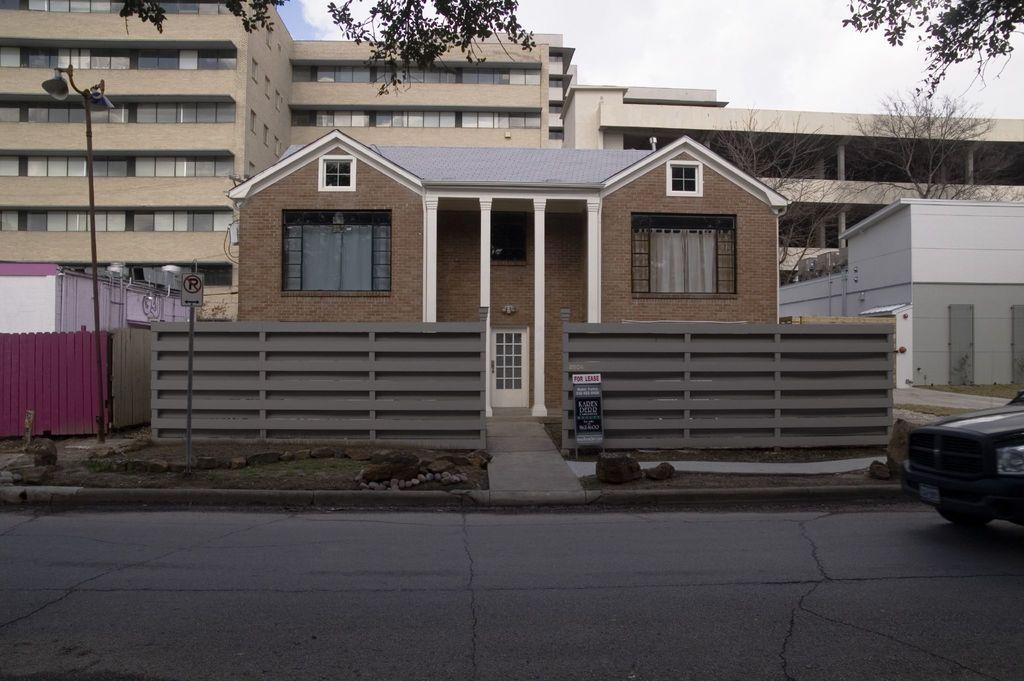What type of structures are present in the image? There are buildings in the image. What colors are the buildings? The buildings are in cream and brown colors. What can be seen in the background of the image? There is a light pole in the background of the image. What is the color of the sky in the image? The sky is white in color. What type of religious ceremony is taking place in the image? There is no indication of a religious ceremony in the image; it features buildings, a light pole, and a white sky. What smell can be detected in the image? There is no information about smells in the image, as it only provides visual information. 